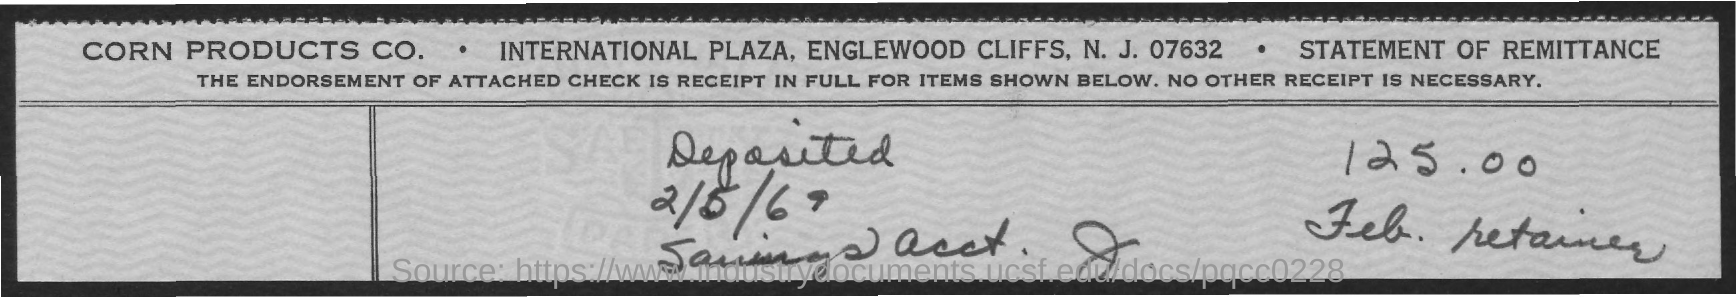Outline some significant characteristics in this image. The amount deposited, as per the document, is 125.00. The deposited date mentioned in this document is 2/5/69. 